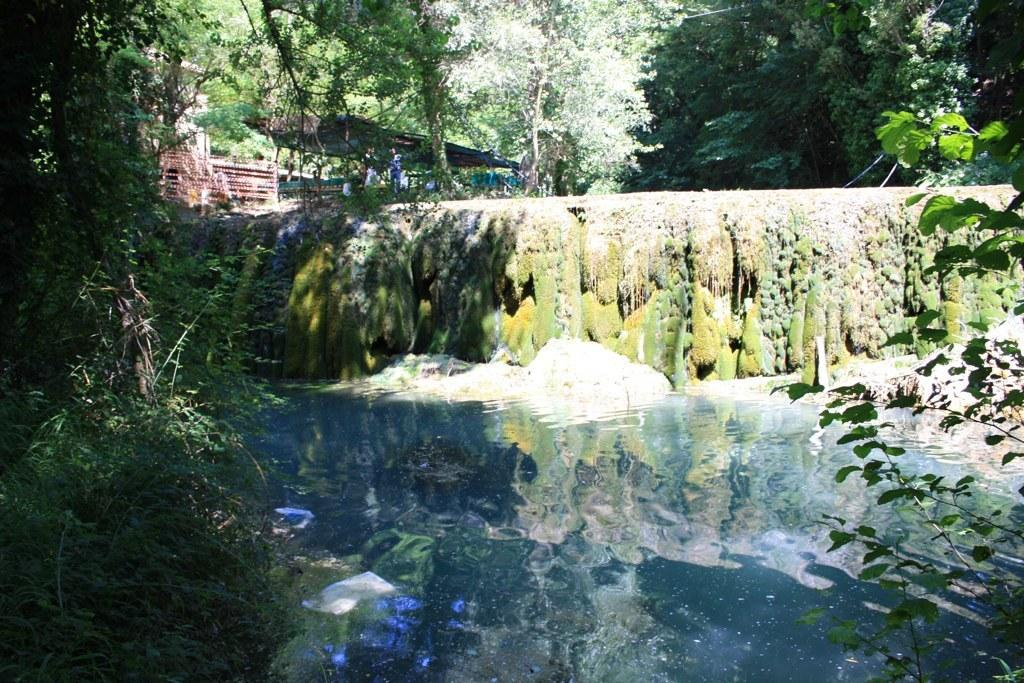What is the primary element visible in the image? There is water in the image. What type of vegetation can be seen around the water? There are trees surrounding the water. What is growing on the wall in the image? There is green-colored algae formed on a wall in the image. What type of loaf is being prepared by the manager in the image? There is no manager or loaf present in the image. 